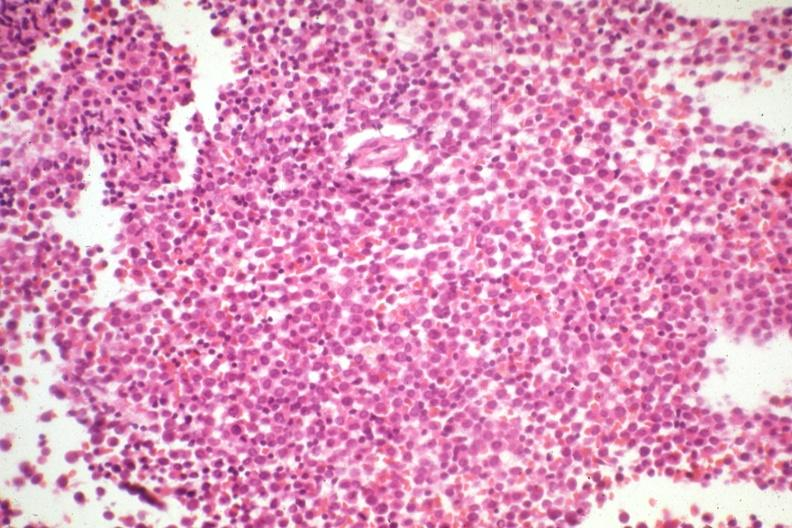s close-up excellent example of interosseous muscle atrophy had not knocked out leukemia cells?
Answer the question using a single word or phrase. No 